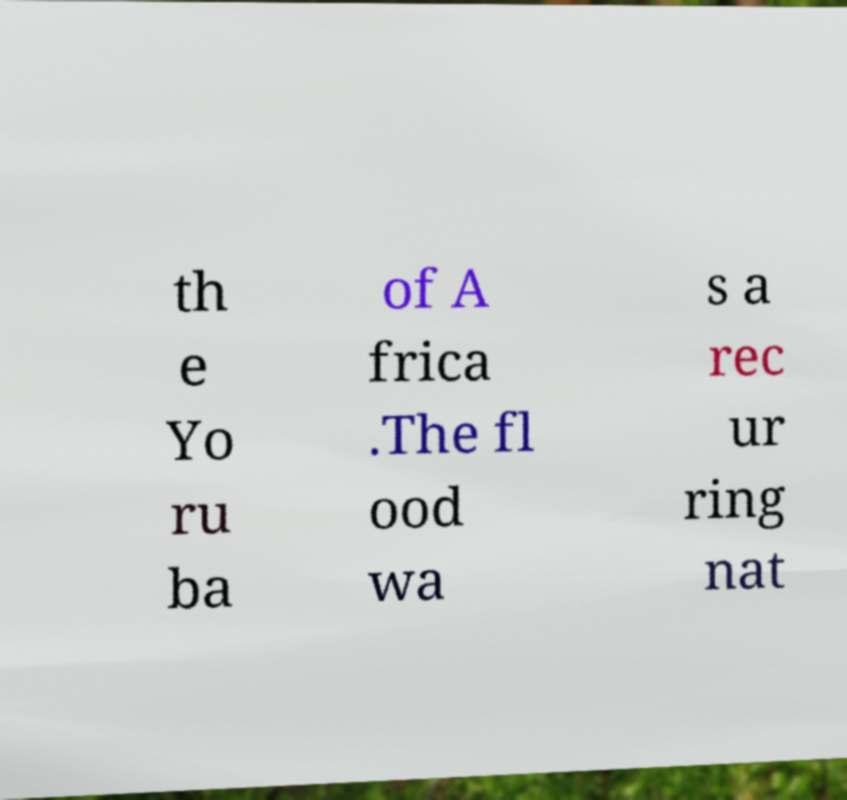Can you accurately transcribe the text from the provided image for me? th e Yo ru ba of A frica .The fl ood wa s a rec ur ring nat 